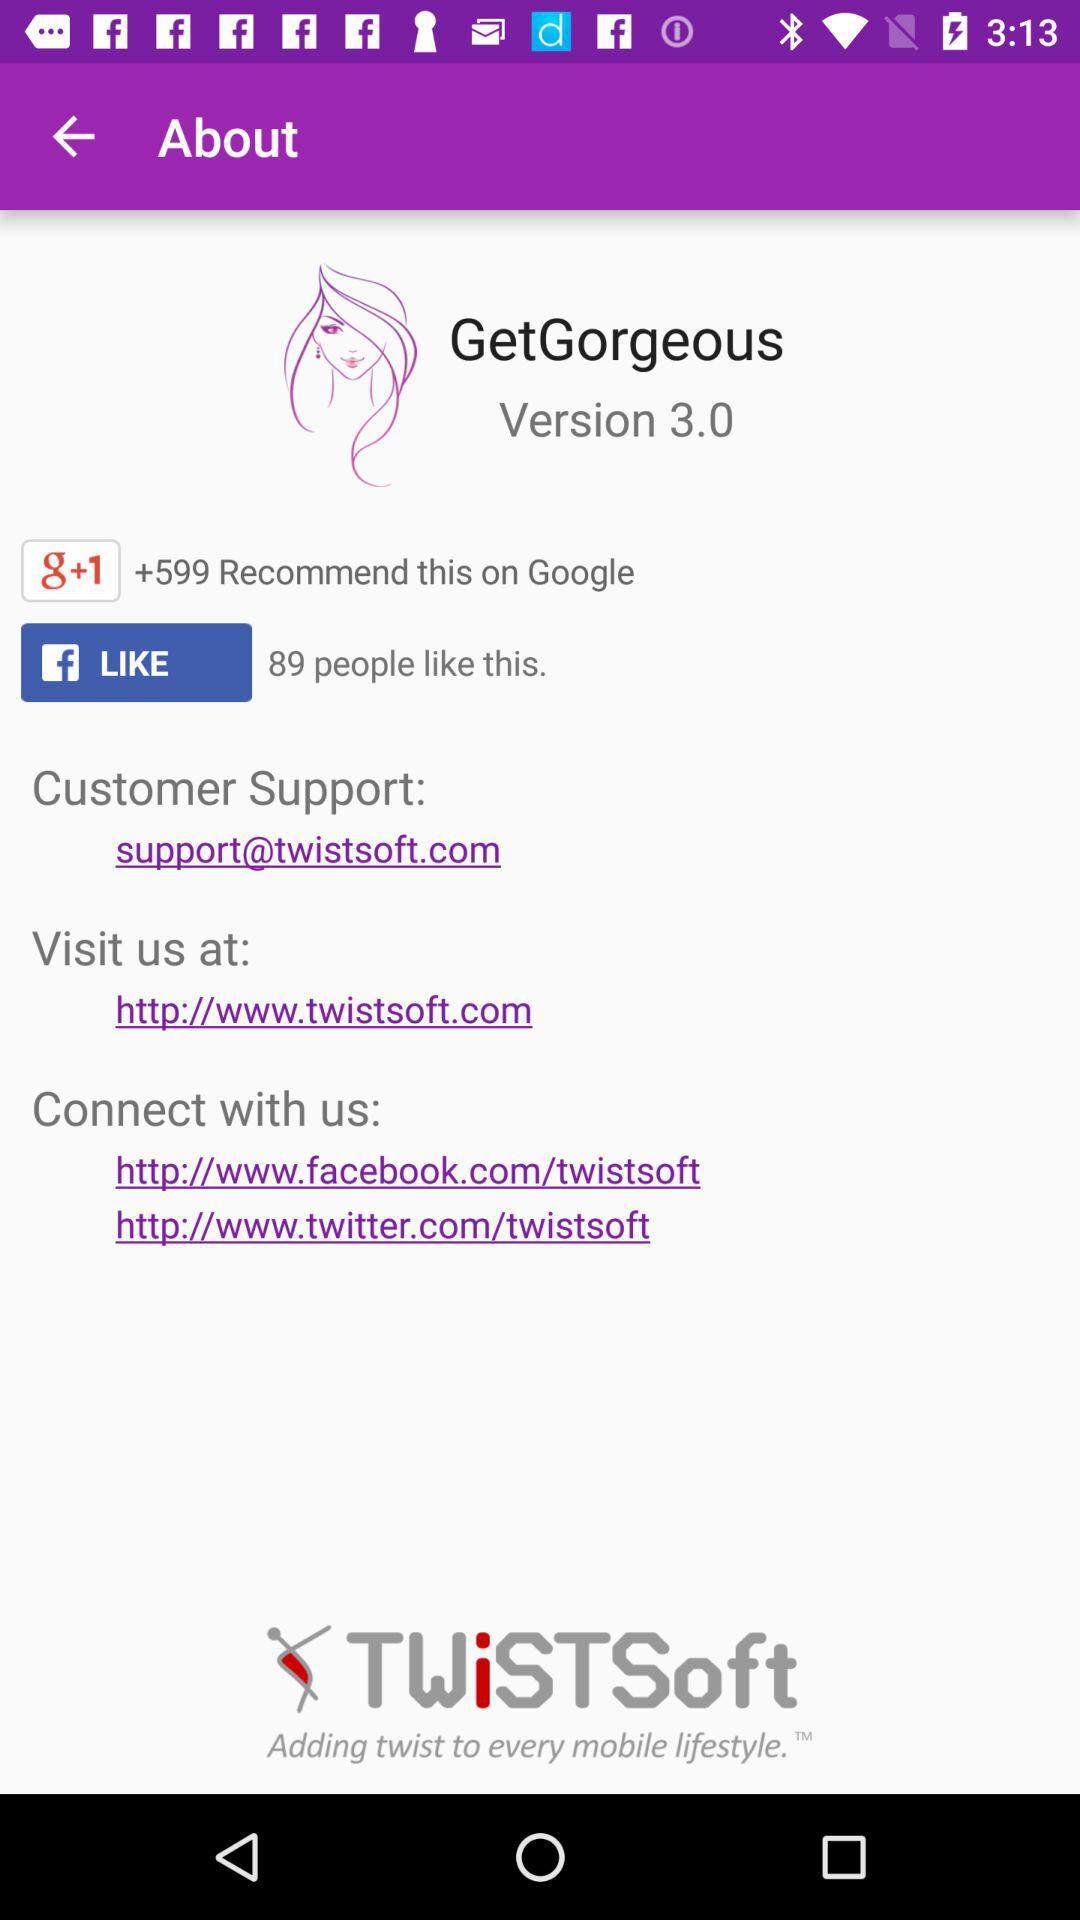What is the email address of "GetGorgeous" customer support? The email address is support@twistsoft.com. 